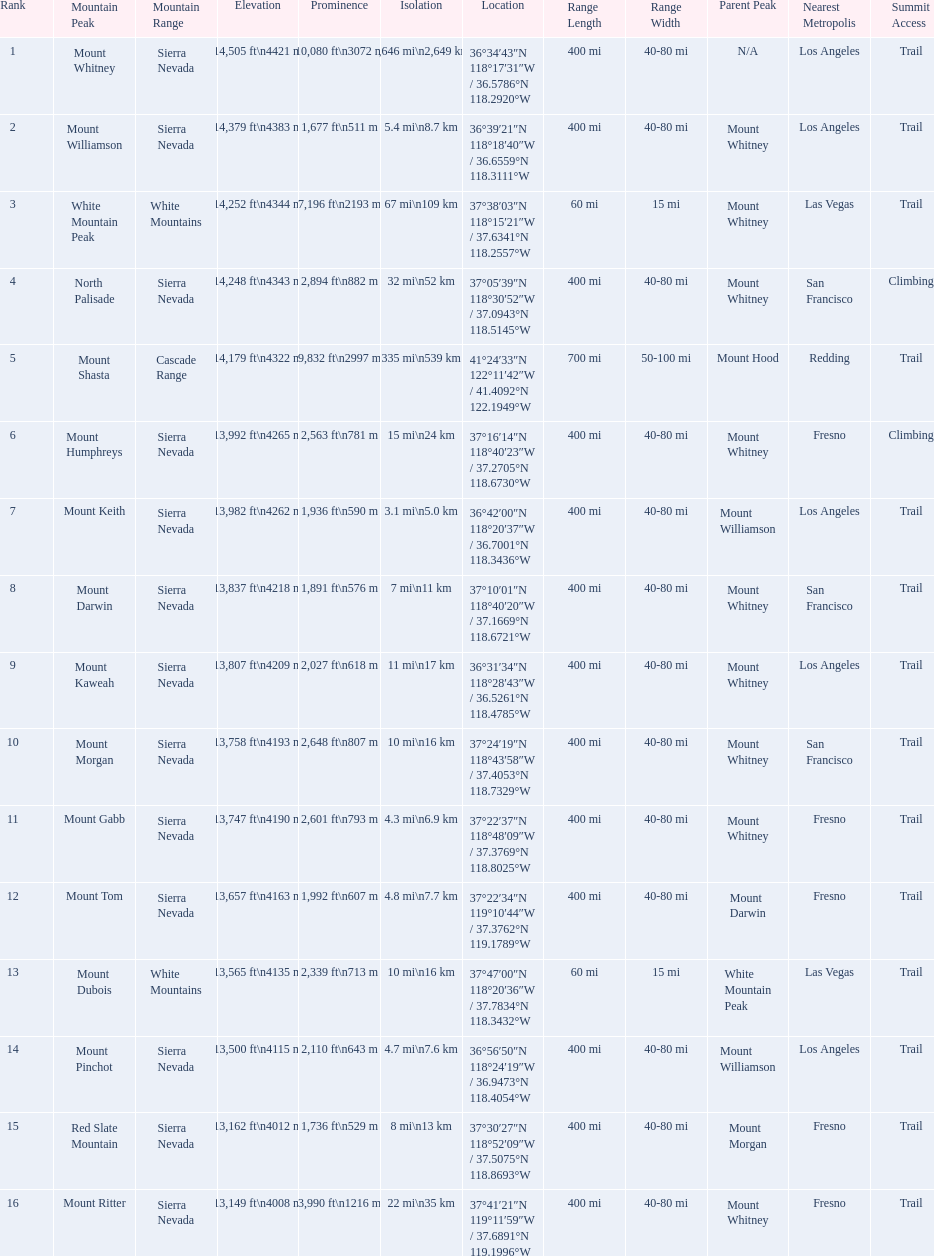What is the total elevation (in ft) of mount whitney? 14,505 ft. 